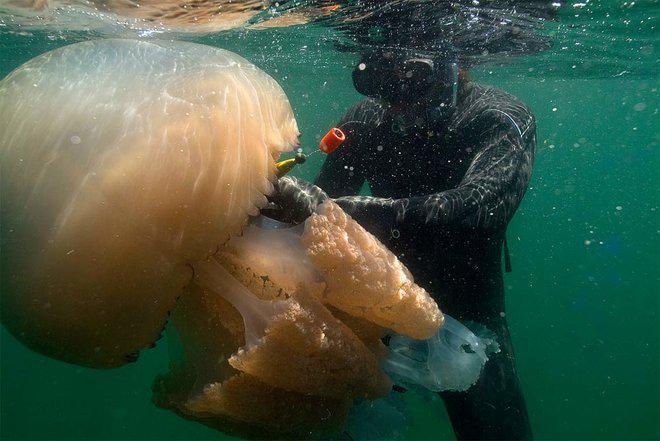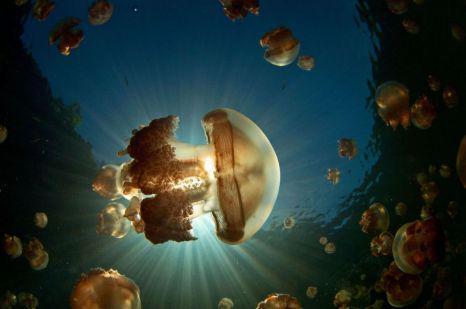The first image is the image on the left, the second image is the image on the right. Examine the images to the left and right. Is the description "A female in flippers is swimming in the image on the left." accurate? Answer yes or no. No. The first image is the image on the left, the second image is the image on the right. For the images shown, is this caption "A diver in a black wetsuit is near at least one pale beige mushroom-look jellyfish." true? Answer yes or no. Yes. 